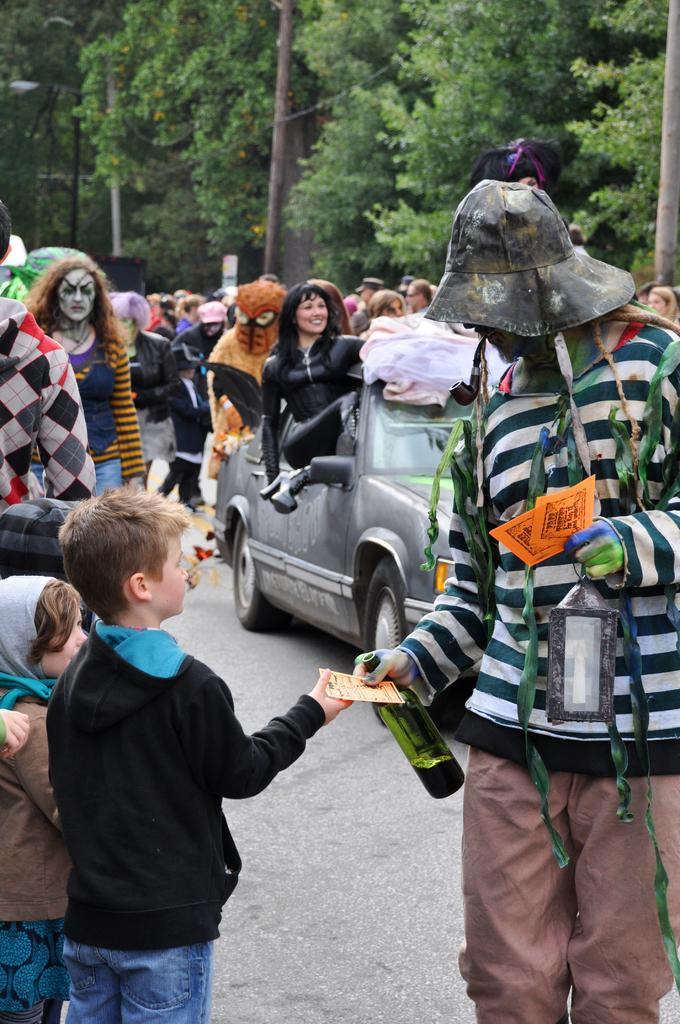What are the people in the image doing? There is a group of persons walking on the road. Can you describe the person on the right side of the road? The person on the right side of the road is holding a bottle in his hand. What is the person on the right side of the road doing with the kid? The person on the right side of the road is giving something to a kid. What type of crib can be seen in the image? There is no crib present in the image. Is there a party happening in the image? There is no indication of a party in the image. 